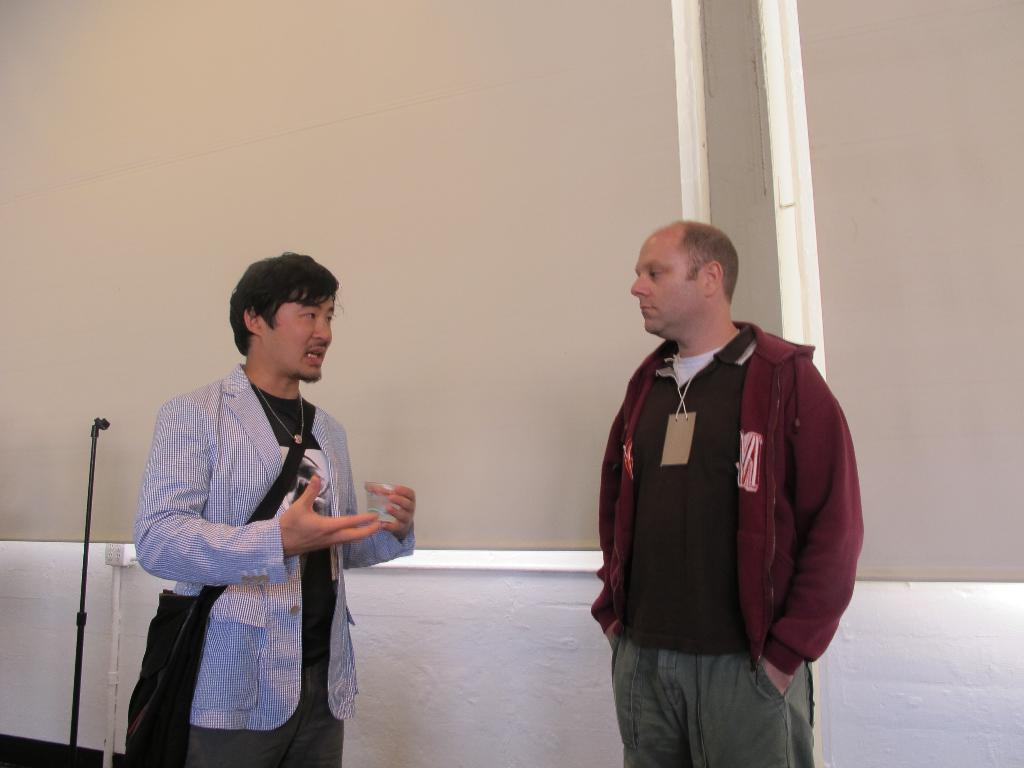How many people are in the image? There are two men in the image. Where are the men located in the image? The men are in the center of the image. What color is the spot on the chin of the man on the left? There is no spot or chin visible on the men in the image. 